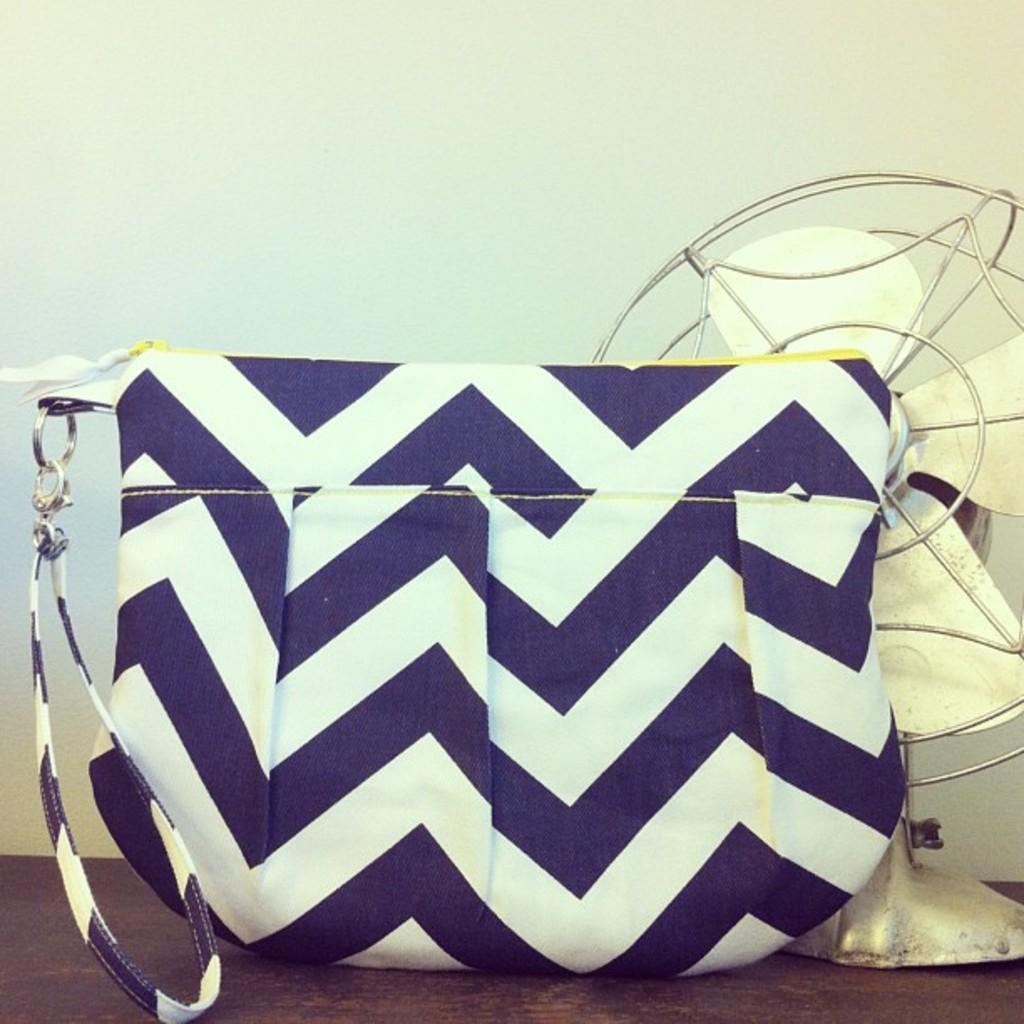Describe this image in one or two sentences. In this picture we can see blue and white lines bag with chain, strap to it and aside to this bag we have a table fan and this two are placed on a table. 